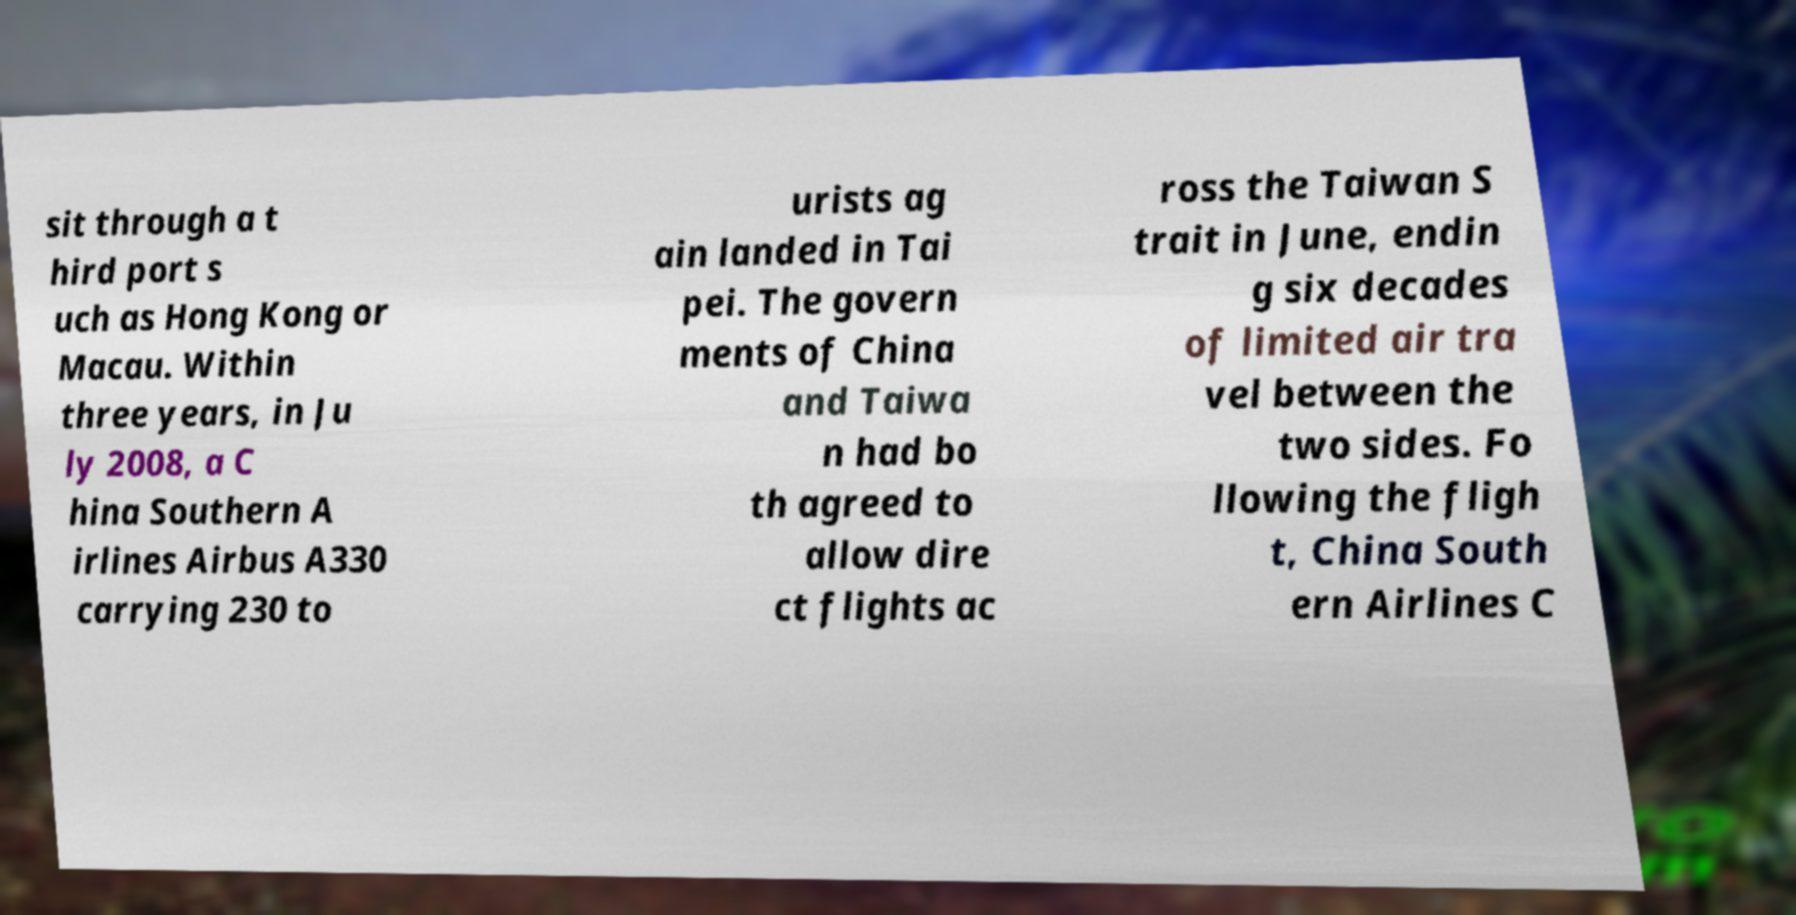What messages or text are displayed in this image? I need them in a readable, typed format. sit through a t hird port s uch as Hong Kong or Macau. Within three years, in Ju ly 2008, a C hina Southern A irlines Airbus A330 carrying 230 to urists ag ain landed in Tai pei. The govern ments of China and Taiwa n had bo th agreed to allow dire ct flights ac ross the Taiwan S trait in June, endin g six decades of limited air tra vel between the two sides. Fo llowing the fligh t, China South ern Airlines C 